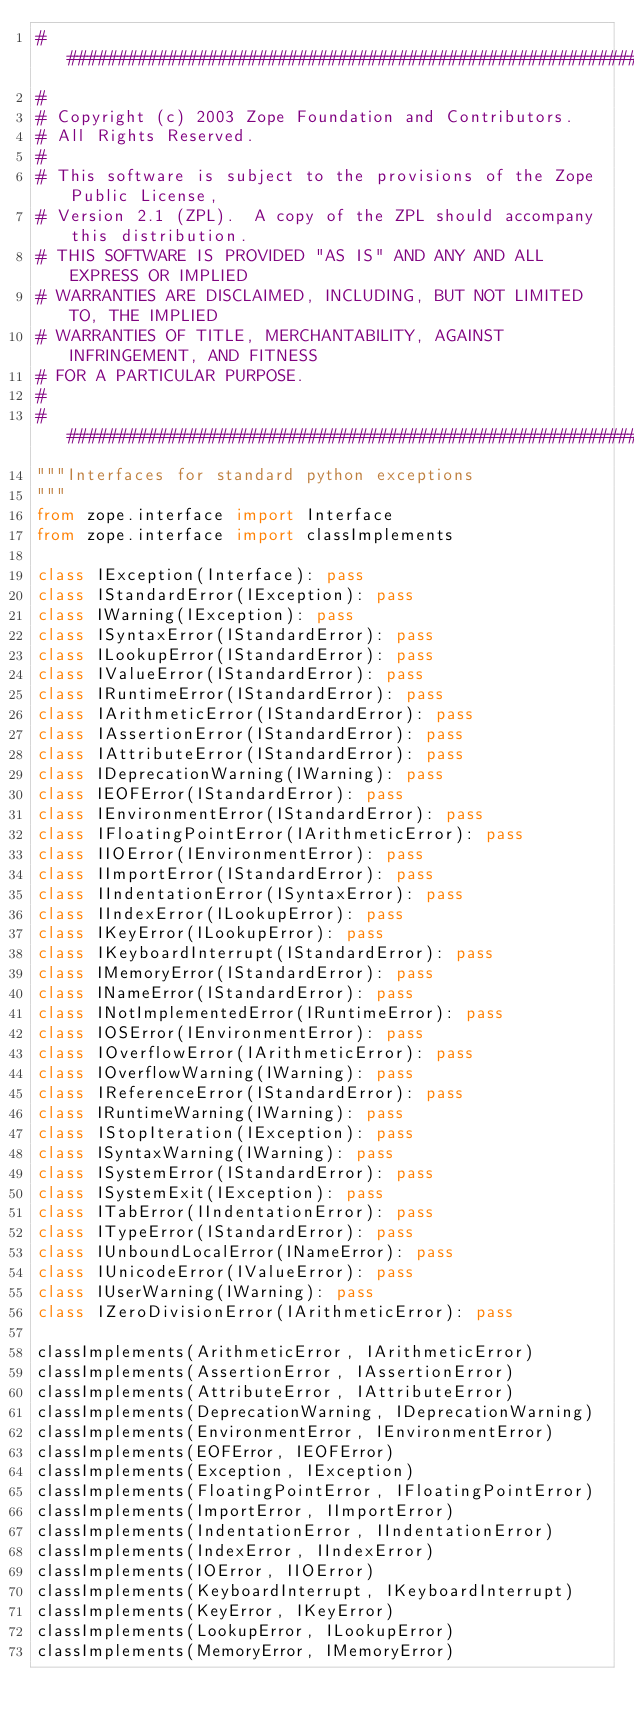Convert code to text. <code><loc_0><loc_0><loc_500><loc_500><_Python_>##############################################################################
#
# Copyright (c) 2003 Zope Foundation and Contributors.
# All Rights Reserved.
#
# This software is subject to the provisions of the Zope Public License,
# Version 2.1 (ZPL).  A copy of the ZPL should accompany this distribution.
# THIS SOFTWARE IS PROVIDED "AS IS" AND ANY AND ALL EXPRESS OR IMPLIED
# WARRANTIES ARE DISCLAIMED, INCLUDING, BUT NOT LIMITED TO, THE IMPLIED
# WARRANTIES OF TITLE, MERCHANTABILITY, AGAINST INFRINGEMENT, AND FITNESS
# FOR A PARTICULAR PURPOSE.
#
##############################################################################
"""Interfaces for standard python exceptions
"""
from zope.interface import Interface
from zope.interface import classImplements

class IException(Interface): pass
class IStandardError(IException): pass
class IWarning(IException): pass
class ISyntaxError(IStandardError): pass
class ILookupError(IStandardError): pass
class IValueError(IStandardError): pass
class IRuntimeError(IStandardError): pass
class IArithmeticError(IStandardError): pass
class IAssertionError(IStandardError): pass
class IAttributeError(IStandardError): pass
class IDeprecationWarning(IWarning): pass
class IEOFError(IStandardError): pass
class IEnvironmentError(IStandardError): pass
class IFloatingPointError(IArithmeticError): pass
class IIOError(IEnvironmentError): pass
class IImportError(IStandardError): pass
class IIndentationError(ISyntaxError): pass
class IIndexError(ILookupError): pass
class IKeyError(ILookupError): pass
class IKeyboardInterrupt(IStandardError): pass
class IMemoryError(IStandardError): pass
class INameError(IStandardError): pass
class INotImplementedError(IRuntimeError): pass
class IOSError(IEnvironmentError): pass
class IOverflowError(IArithmeticError): pass
class IOverflowWarning(IWarning): pass
class IReferenceError(IStandardError): pass
class IRuntimeWarning(IWarning): pass
class IStopIteration(IException): pass
class ISyntaxWarning(IWarning): pass
class ISystemError(IStandardError): pass
class ISystemExit(IException): pass
class ITabError(IIndentationError): pass
class ITypeError(IStandardError): pass
class IUnboundLocalError(INameError): pass
class IUnicodeError(IValueError): pass
class IUserWarning(IWarning): pass
class IZeroDivisionError(IArithmeticError): pass

classImplements(ArithmeticError, IArithmeticError)
classImplements(AssertionError, IAssertionError)
classImplements(AttributeError, IAttributeError)
classImplements(DeprecationWarning, IDeprecationWarning)
classImplements(EnvironmentError, IEnvironmentError)
classImplements(EOFError, IEOFError)
classImplements(Exception, IException)
classImplements(FloatingPointError, IFloatingPointError)
classImplements(ImportError, IImportError)
classImplements(IndentationError, IIndentationError)
classImplements(IndexError, IIndexError)
classImplements(IOError, IIOError)
classImplements(KeyboardInterrupt, IKeyboardInterrupt)
classImplements(KeyError, IKeyError)
classImplements(LookupError, ILookupError)
classImplements(MemoryError, IMemoryError)</code> 